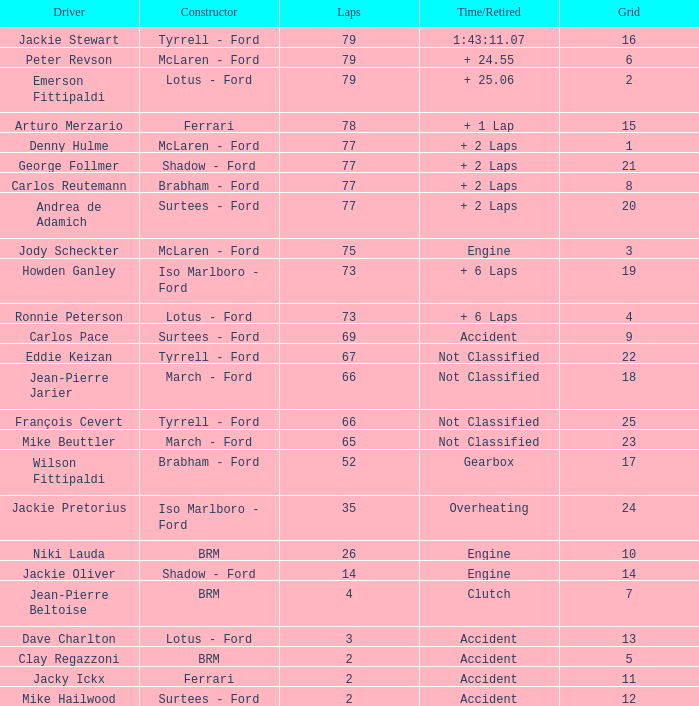How much time is required for less than 35 laps and less than 10 grids? Clutch, Accident. Would you be able to parse every entry in this table? {'header': ['Driver', 'Constructor', 'Laps', 'Time/Retired', 'Grid'], 'rows': [['Jackie Stewart', 'Tyrrell - Ford', '79', '1:43:11.07', '16'], ['Peter Revson', 'McLaren - Ford', '79', '+ 24.55', '6'], ['Emerson Fittipaldi', 'Lotus - Ford', '79', '+ 25.06', '2'], ['Arturo Merzario', 'Ferrari', '78', '+ 1 Lap', '15'], ['Denny Hulme', 'McLaren - Ford', '77', '+ 2 Laps', '1'], ['George Follmer', 'Shadow - Ford', '77', '+ 2 Laps', '21'], ['Carlos Reutemann', 'Brabham - Ford', '77', '+ 2 Laps', '8'], ['Andrea de Adamich', 'Surtees - Ford', '77', '+ 2 Laps', '20'], ['Jody Scheckter', 'McLaren - Ford', '75', 'Engine', '3'], ['Howden Ganley', 'Iso Marlboro - Ford', '73', '+ 6 Laps', '19'], ['Ronnie Peterson', 'Lotus - Ford', '73', '+ 6 Laps', '4'], ['Carlos Pace', 'Surtees - Ford', '69', 'Accident', '9'], ['Eddie Keizan', 'Tyrrell - Ford', '67', 'Not Classified', '22'], ['Jean-Pierre Jarier', 'March - Ford', '66', 'Not Classified', '18'], ['François Cevert', 'Tyrrell - Ford', '66', 'Not Classified', '25'], ['Mike Beuttler', 'March - Ford', '65', 'Not Classified', '23'], ['Wilson Fittipaldi', 'Brabham - Ford', '52', 'Gearbox', '17'], ['Jackie Pretorius', 'Iso Marlboro - Ford', '35', 'Overheating', '24'], ['Niki Lauda', 'BRM', '26', 'Engine', '10'], ['Jackie Oliver', 'Shadow - Ford', '14', 'Engine', '14'], ['Jean-Pierre Beltoise', 'BRM', '4', 'Clutch', '7'], ['Dave Charlton', 'Lotus - Ford', '3', 'Accident', '13'], ['Clay Regazzoni', 'BRM', '2', 'Accident', '5'], ['Jacky Ickx', 'Ferrari', '2', 'Accident', '11'], ['Mike Hailwood', 'Surtees - Ford', '2', 'Accident', '12']]} 